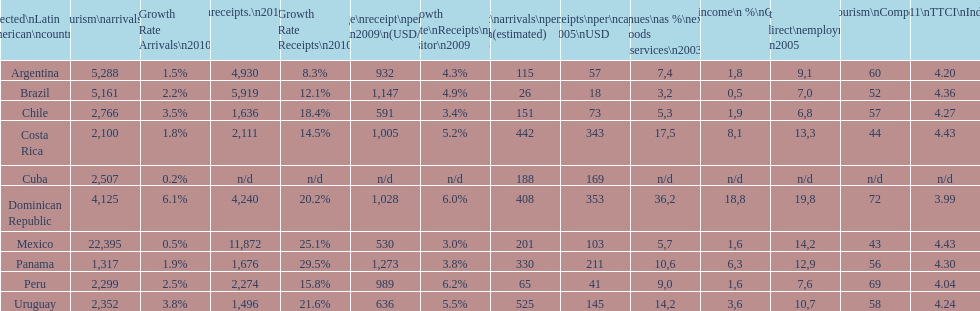How many dollars on average did brazil receive per tourist in 2009? 1,147. 